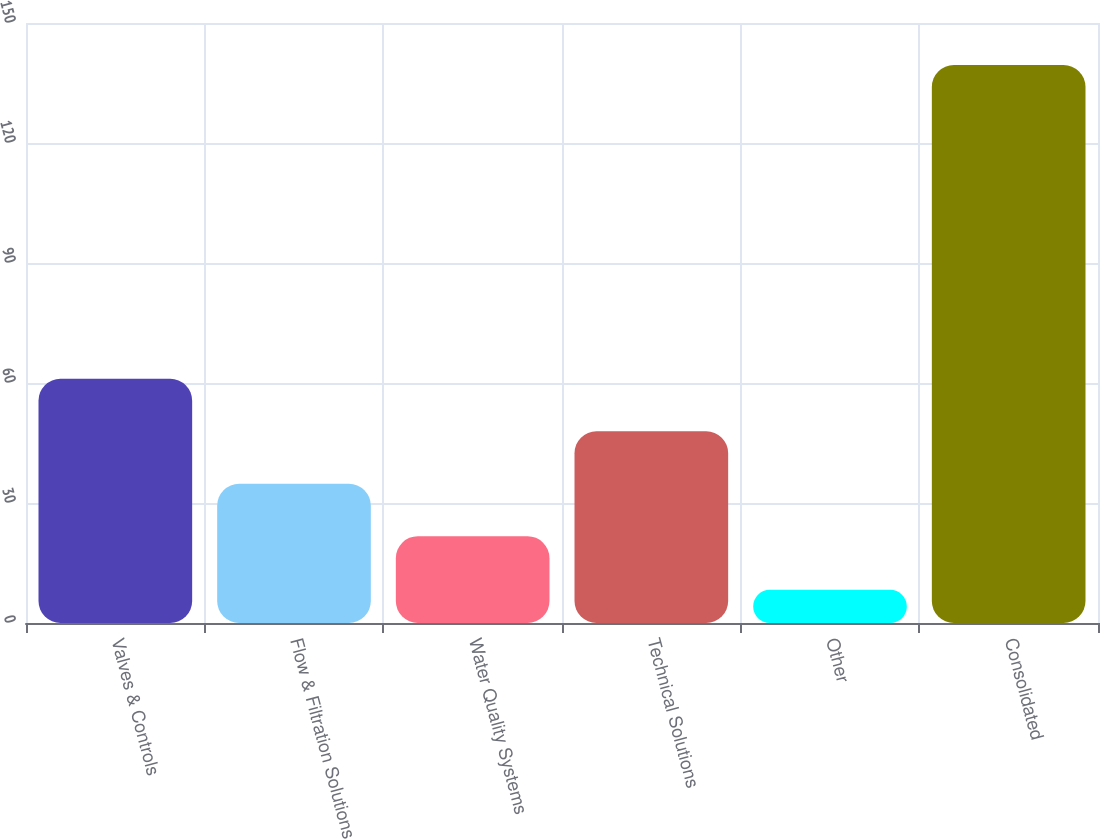<chart> <loc_0><loc_0><loc_500><loc_500><bar_chart><fcel>Valves & Controls<fcel>Flow & Filtration Solutions<fcel>Water Quality Systems<fcel>Technical Solutions<fcel>Other<fcel>Consolidated<nl><fcel>61.06<fcel>34.82<fcel>21.7<fcel>47.94<fcel>8.3<fcel>139.5<nl></chart> 